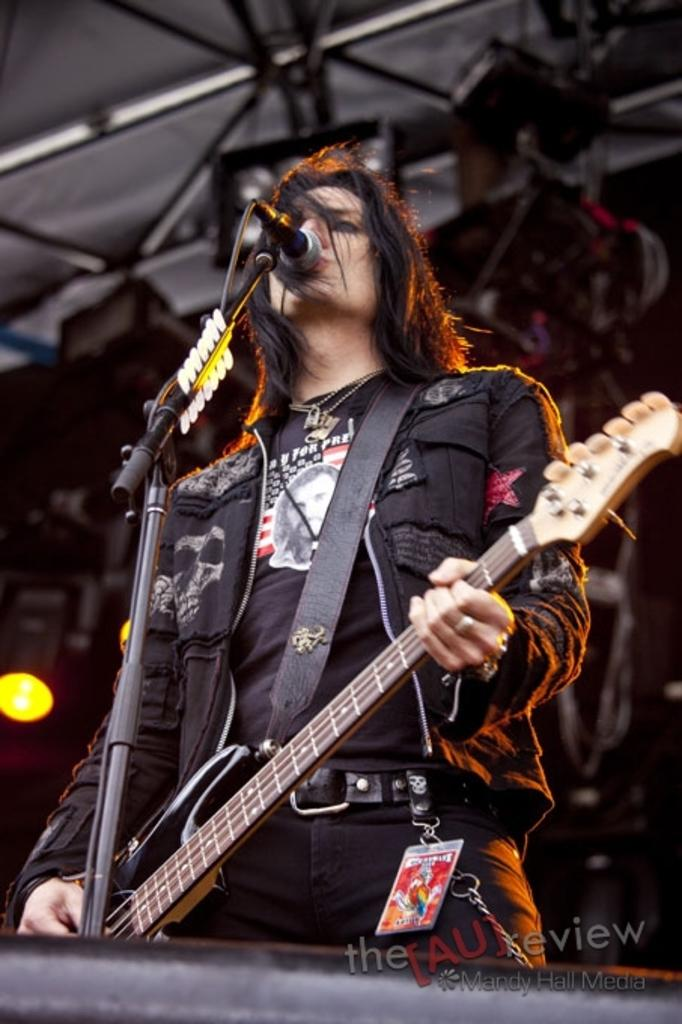What is the main subject of the image? There is a person in the image. What is the person doing in the image? The person is standing and holding a guitar. What other object is present in the image? There is a microphone (mic) in the image. What type of wool is being spun by the person in the image? There is no wool or spinning activity present in the image; the person is holding a guitar and standing near a microphone. 